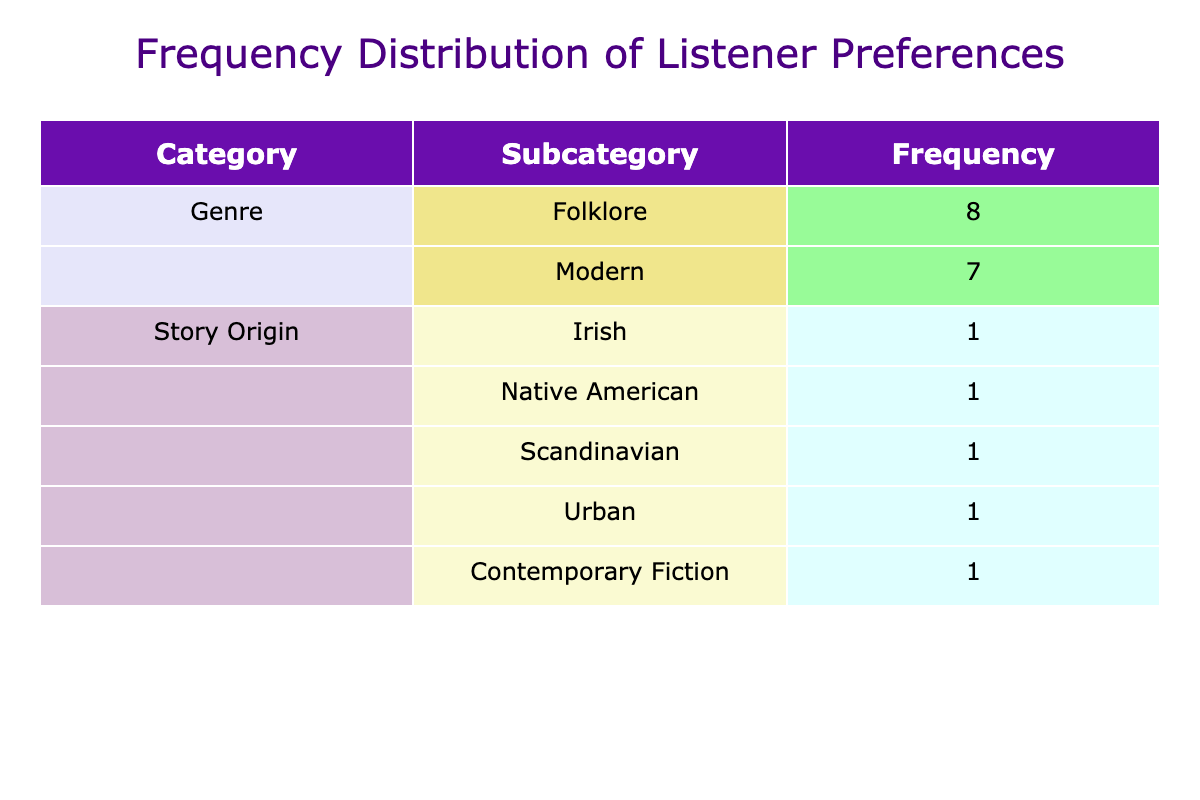What is the frequency of listeners preferring folklore music? The table shows that the frequency for the 'Folklore' genre is 8, which is the count of listener IDs that have this preference.
Answer: 8 What is the total frequency of listeners who prefer modern stories? The total frequency for the 'Modern' genre is 7, calculated from the count of listener IDs in the modern category.
Answer: 7 Which story origin has the highest frequency among listeners? The highest frequency in the 'Story Origin' category is for 'African', with a count of 1, as it appears only once in the data.
Answer: African Is the preference score higher for folklore or modern stories? The average preference score for folklore is (85 + 75 + 90 + 80 + 95 + 88 + 78 + 81) / 8 = 83.875, while for modern, it is (60 + 70 + 65 + 55 + 72 + 58 + 62) / 7 = 63.43. Since 83.875 > 63.43, folklore has a higher preference score.
Answer: Folklore What is the average preference score for story origins from folklore? Adding the preference scores for folklore origins gives (85 + 75 + 90 + 80 + 95 + 88 + 78 + 81) =  81.875; with 8 origins, dividing 81.875 by 8 gives an average of 81.875.
Answer: 81.875 Do more listeners prefer folklore stories than modern stories? Yes, the total listeners for folklore is 8 and for modern is 7, indicating more listeners prefer folklore.
Answer: Yes What is the least preferred story origin among modern stories? The story origin 'Romantic Comedy' under modern shows the lowest preference score of 55.
Answer: Romantic Comedy How many different folklore story origins are present in the data? Counting the unique story origins listed under the folklore genre reveals there are 8 (including Irish, Native American, etc.).
Answer: 8 Which category has more unique entries, folklore or modern? Folklore has 8 unique story origins (e.g., Irish, Japanese, African) while modern has 7 unique story origins (e.g., Urban, Dystopian). Thus, folklore has more unique entries.
Answer: Folklore 